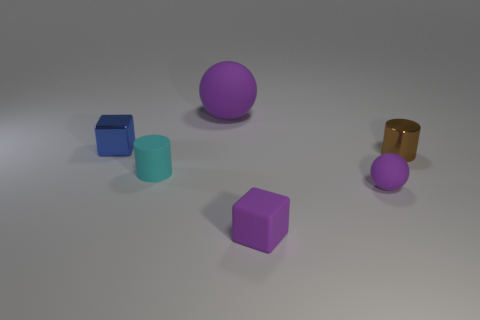Is the number of purple rubber blocks behind the tiny cyan rubber cylinder greater than the number of tiny cyan things?
Your answer should be very brief. No. The large thing that is the same color as the rubber block is what shape?
Make the answer very short. Sphere. Is there a cylinder that has the same material as the purple cube?
Keep it short and to the point. Yes. Are the ball in front of the brown cylinder and the ball behind the rubber cylinder made of the same material?
Give a very brief answer. Yes. Are there an equal number of tiny spheres that are to the left of the blue thing and purple blocks to the left of the tiny sphere?
Your answer should be compact. No. What color is the metallic block that is the same size as the brown metal object?
Ensure brevity in your answer.  Blue. Are there any small cylinders that have the same color as the metallic block?
Keep it short and to the point. No. How many things are either purple matte objects that are in front of the brown shiny cylinder or large purple matte cylinders?
Provide a succinct answer. 2. There is a cube that is behind the purple rubber ball that is in front of the purple rubber ball that is behind the tiny shiny block; what is it made of?
Provide a short and direct response. Metal. How many cylinders are either cyan matte things or tiny metallic objects?
Offer a terse response. 2. 